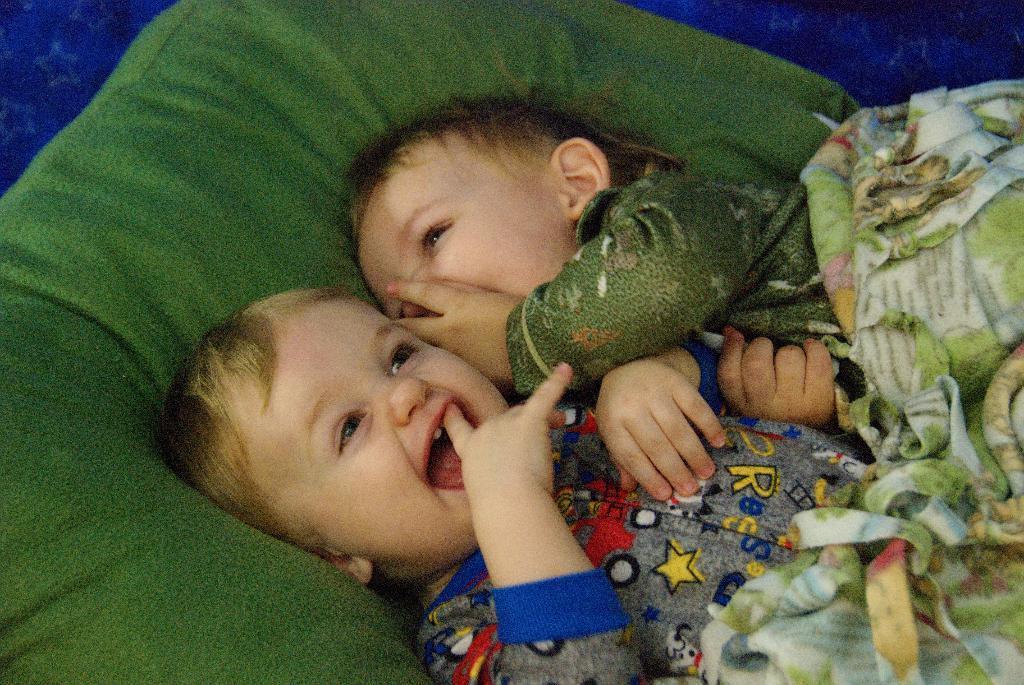How would you summarize this image in a sentence or two? In this image I can see there are two babies laying on green color bed and upon the bed I can see a green color bed sheet and they are smiling 